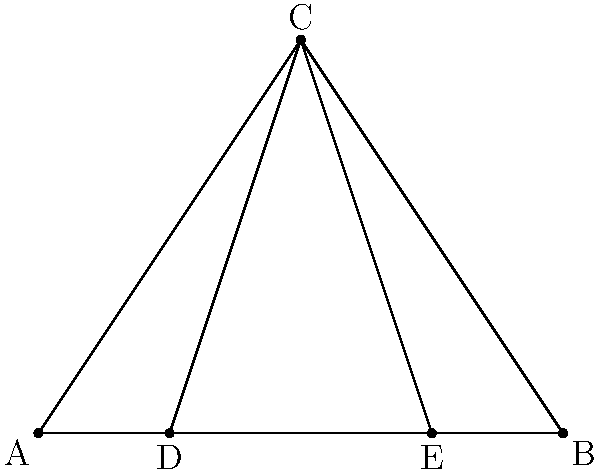In a Wild West saloon, a cowboy's boot spur forms a triangle ABC on the wooden floor. The spur's rowel creates two additional lines from point C to points D and E on AB. If AD = 1 inch, DE = 2 inches, and EB = 1 inch, prove that triangles ACD and BCE are congruent. Let's approach this step-by-step:

1) First, we need to identify what we know:
   - AB = 4 inches (AD + DE + EB = 1 + 2 + 1 = 4)
   - AD = 1 inch
   - DE = 2 inches
   - EB = 1 inch

2) To prove that triangles ACD and BCE are congruent, we need to use the Side-Angle-Side (SAS) congruence criterion.

3) Let's start with the sides:
   - AC is common to both triangles
   - AD = EB (both are 1 inch)

4) Now, we need to prove that angles CAD and CBE are equal:
   - In triangle ABC, CD and CE are medians (they connect a vertex to the midpoint of the opposite side)
   - DE is the midsegment of triangle ABC parallel to AC
   - In any triangle, a median divides the opposite side into two equal parts
   - Therefore, AD = DB = 2 inches

5) Since AD = DB:
   - Triangle ACD is similar to triangle BEC (by SAS similarity)
   - This means that angles CAD and CBE are equal

6) Now we have:
   - AC is common to both triangles
   - AD = EB
   - Angle CAD = Angle CBE

7) By the SAS congruence criterion, triangles ACD and BCE are congruent.
Answer: Triangles ACD and BCE are congruent by SAS. 